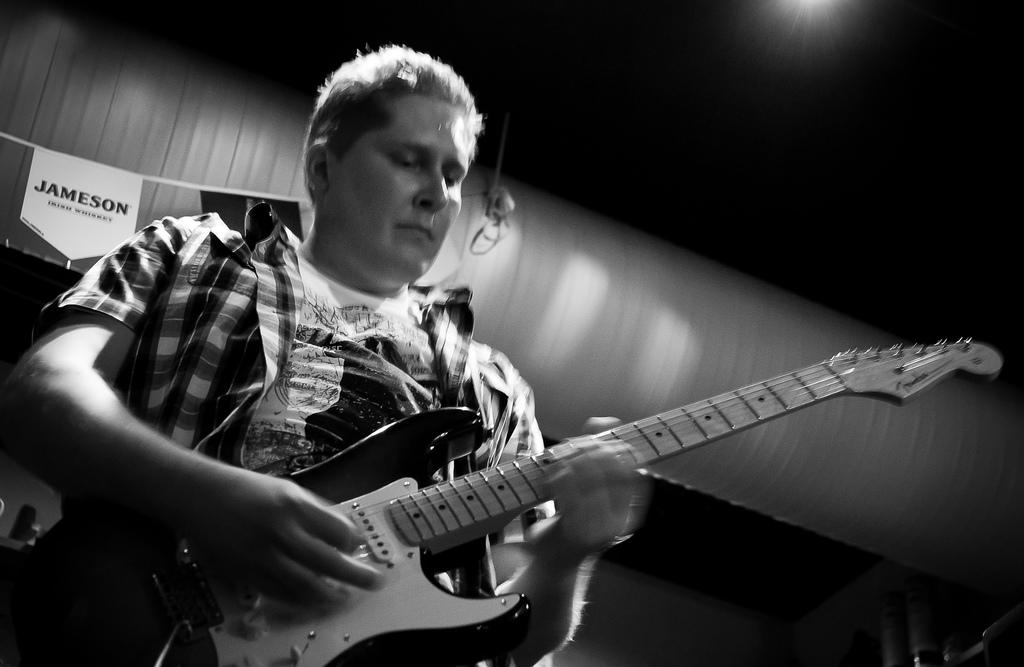What is the main subject of the image? The main subject of the image is a man. What is the man holding in the image? The man is holding a guitar in the image. What type of clothing is the man wearing? The man is wearing a shirt in the image. What type of skin condition can be seen on the man's face in the image? There is no indication of any skin condition on the man's face in the image. What direction is the man facing in the image? The image does not provide enough information to determine the direction the man is facing. 